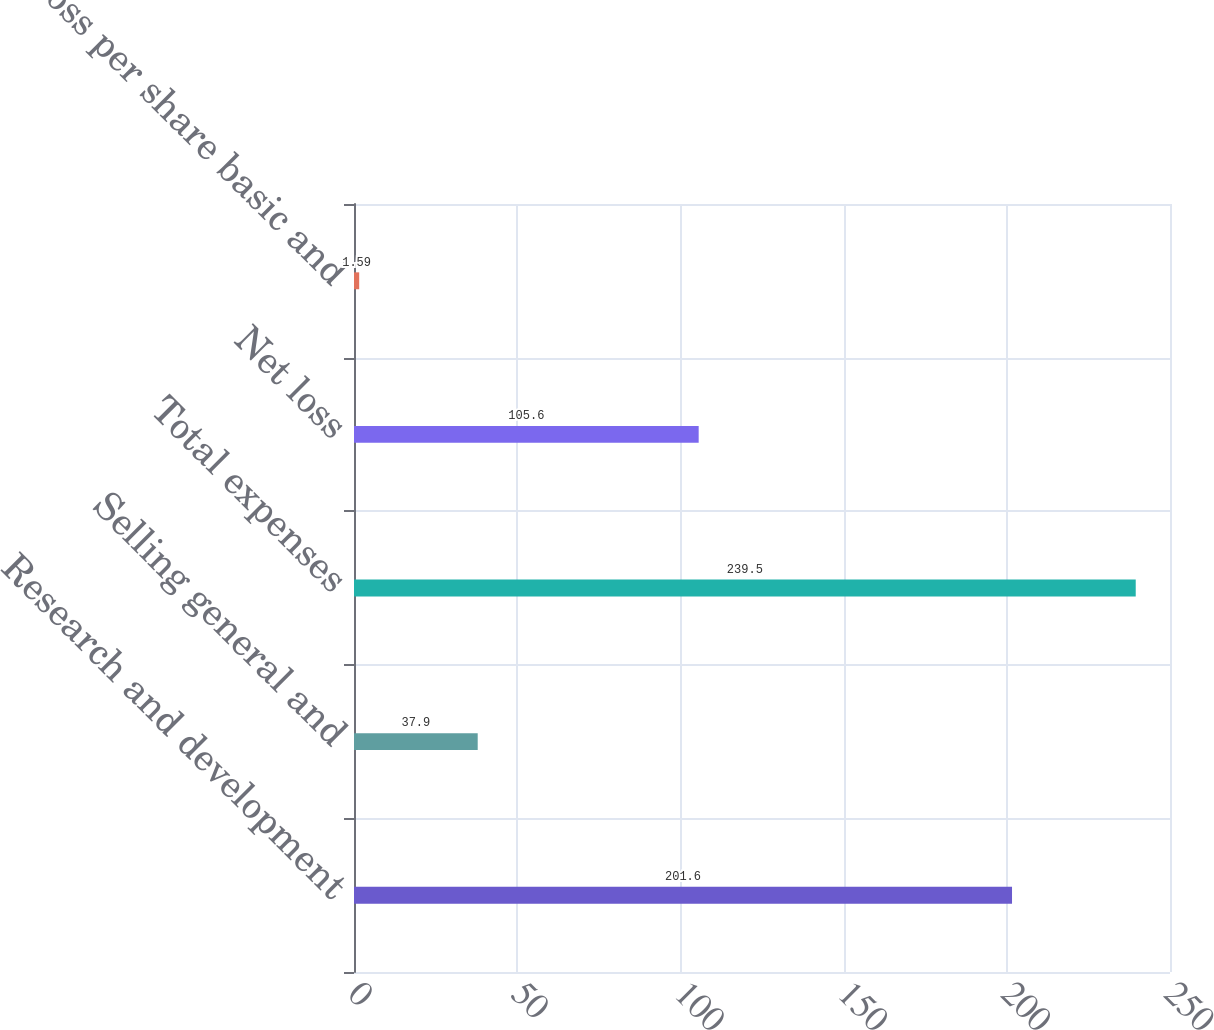<chart> <loc_0><loc_0><loc_500><loc_500><bar_chart><fcel>Research and development<fcel>Selling general and<fcel>Total expenses<fcel>Net loss<fcel>Net loss per share basic and<nl><fcel>201.6<fcel>37.9<fcel>239.5<fcel>105.6<fcel>1.59<nl></chart> 